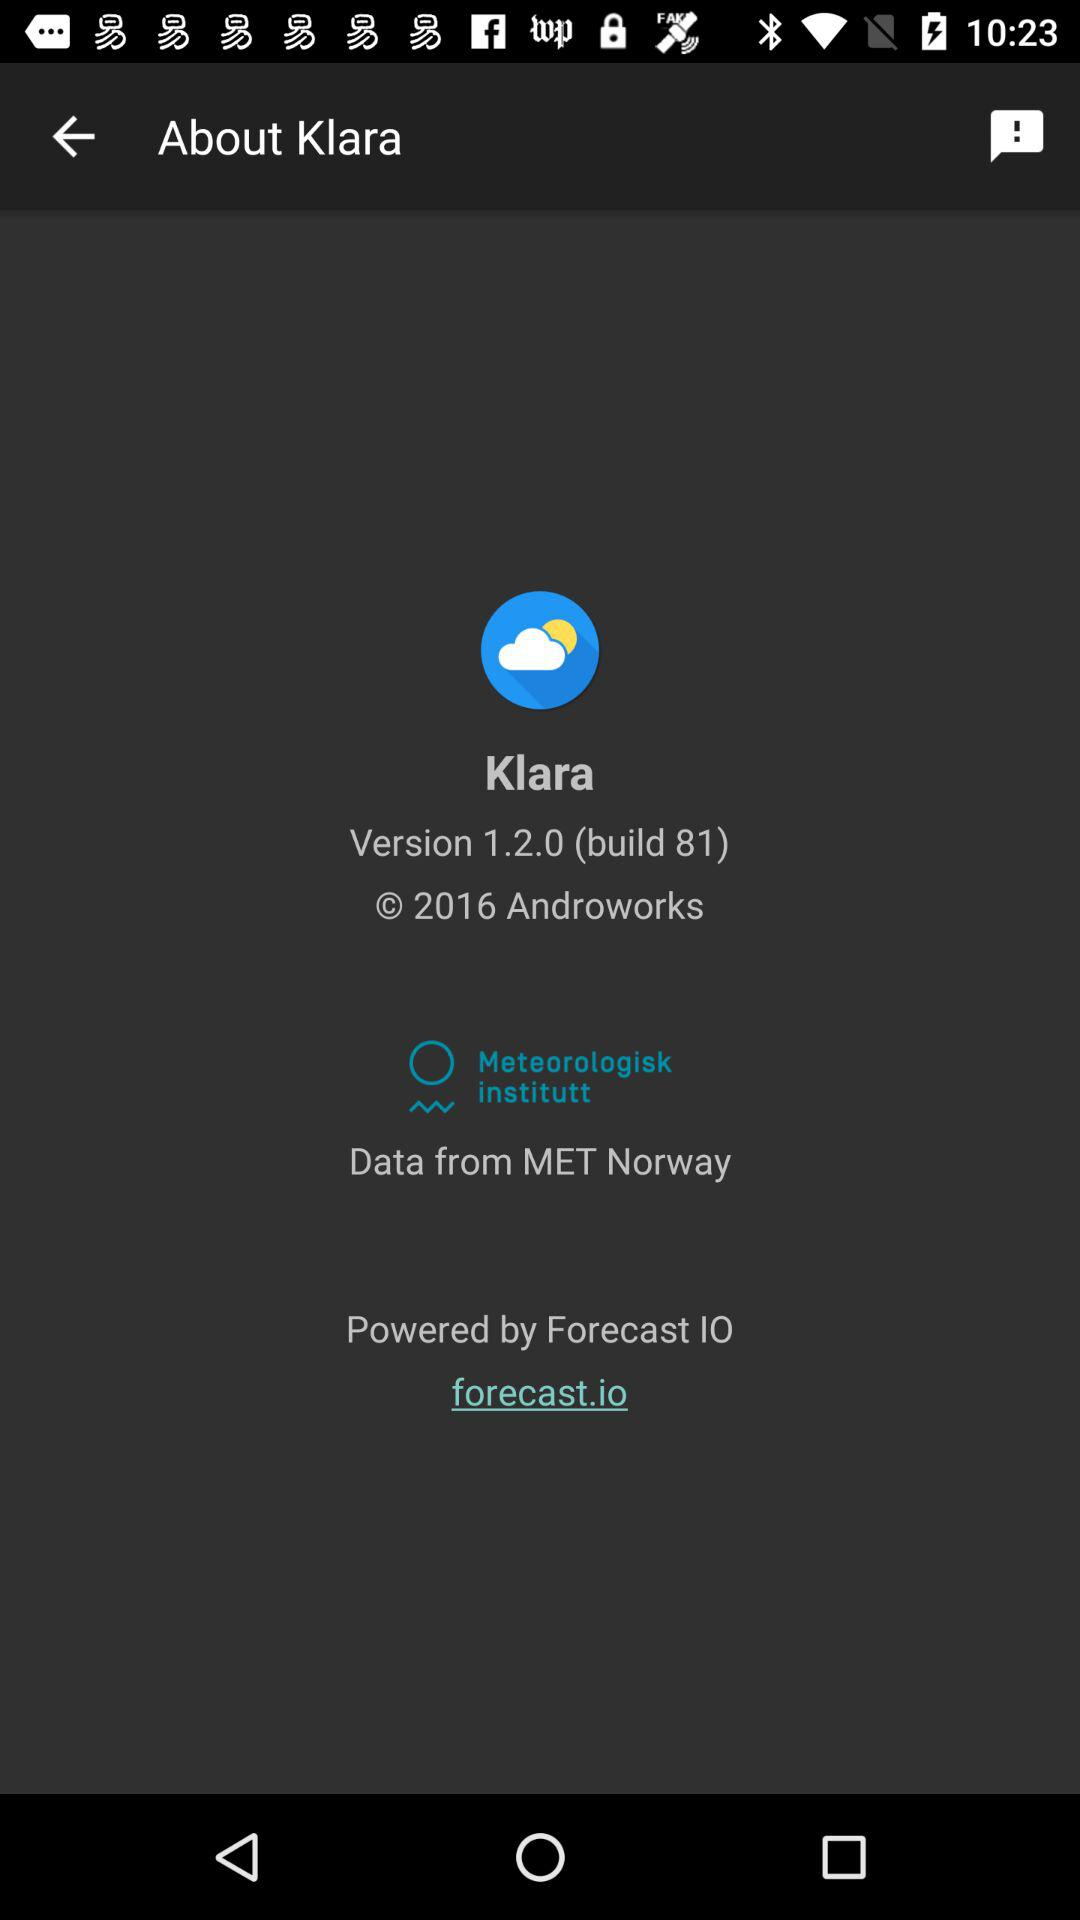Which version of the application is used? The used version is 1.2.0 (build 81). 